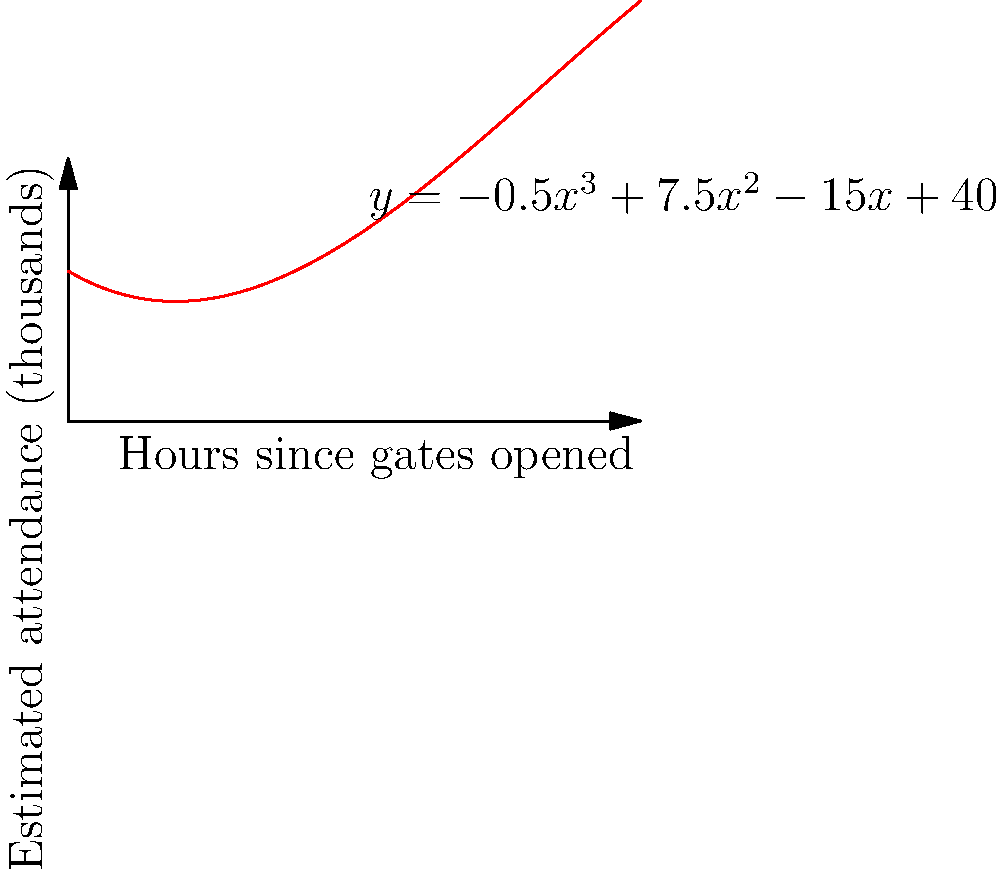A baseball stadium uses a polynomial regression curve to estimate attendance over time during a game. The curve is given by the equation $y = -0.5x^3 + 7.5x^2 - 15x + 40$, where $y$ represents the estimated attendance in thousands and $x$ represents the number of hours since the gates opened. According to this model, approximately how many hours after the gates opened did the attendance reach its peak? To find the peak attendance, we need to determine when the derivative of the function equals zero:

1) The derivative of $y = -0.5x^3 + 7.5x^2 - 15x + 40$ is:
   $y' = -1.5x^2 + 15x - 15$

2) Set the derivative to zero:
   $-1.5x^2 + 15x - 15 = 0$

3) This is a quadratic equation. We can solve it using the quadratic formula:
   $x = \frac{-b \pm \sqrt{b^2 - 4ac}}{2a}$

   Where $a = -1.5$, $b = 15$, and $c = -15$

4) Plugging in these values:
   $x = \frac{-15 \pm \sqrt{15^2 - 4(-1.5)(-15)}}{2(-1.5)}$

5) Simplifying:
   $x = \frac{-15 \pm \sqrt{225 - 90}}{-3} = \frac{-15 \pm \sqrt{135}}{-3}$

6) This gives us two solutions:
   $x \approx 1.32$ or $x \approx 7.68$

7) Since the game likely doesn't last 7.68 hours, the relevant solution is $x \approx 1.32$ hours.

Therefore, the attendance reached its peak approximately 1.32 hours (or about 1 hour and 19 minutes) after the gates opened.
Answer: 1.32 hours 